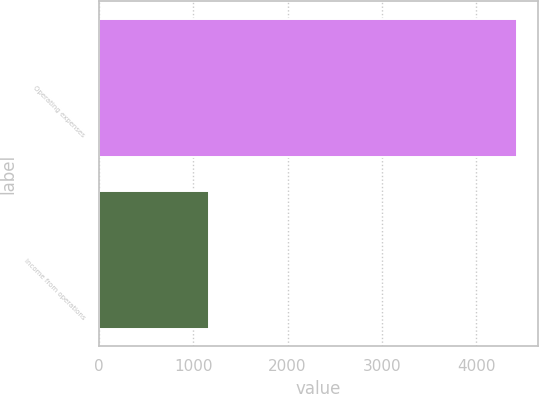<chart> <loc_0><loc_0><loc_500><loc_500><bar_chart><fcel>Operating expenses<fcel>Income from operations<nl><fcel>4435<fcel>1170<nl></chart> 